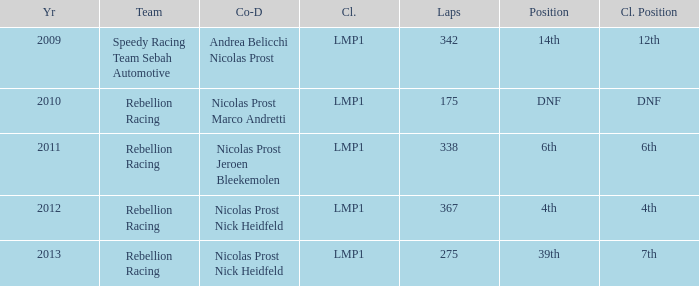What was the class position of the team that was in the 4th position? 4th. 